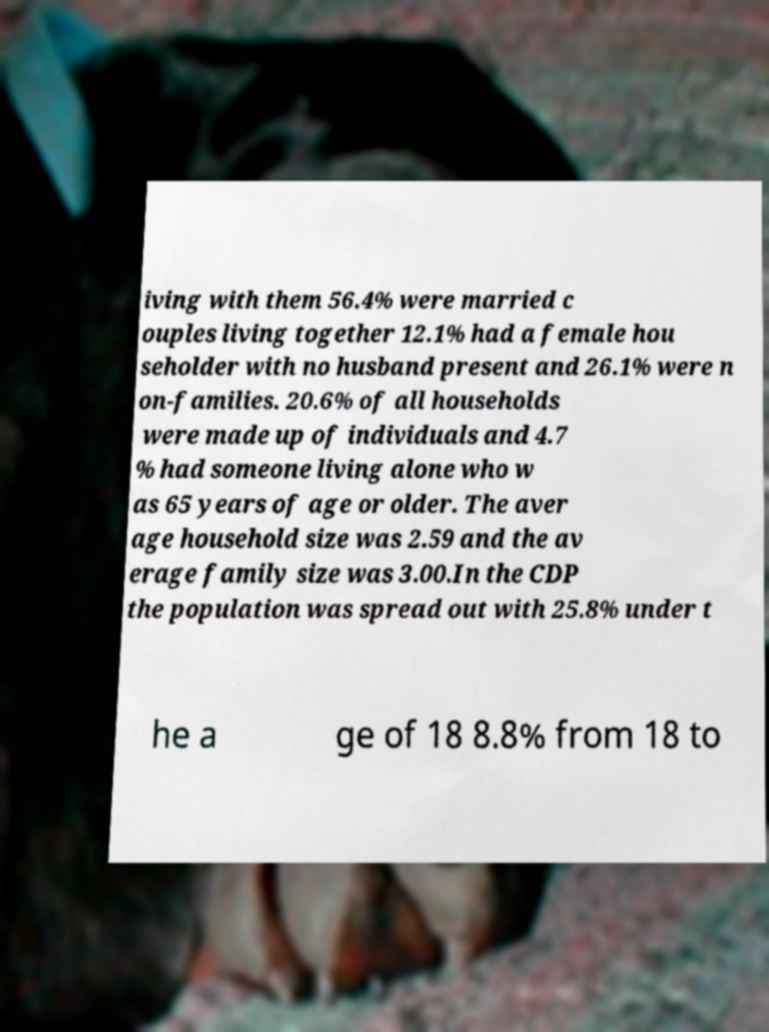There's text embedded in this image that I need extracted. Can you transcribe it verbatim? iving with them 56.4% were married c ouples living together 12.1% had a female hou seholder with no husband present and 26.1% were n on-families. 20.6% of all households were made up of individuals and 4.7 % had someone living alone who w as 65 years of age or older. The aver age household size was 2.59 and the av erage family size was 3.00.In the CDP the population was spread out with 25.8% under t he a ge of 18 8.8% from 18 to 